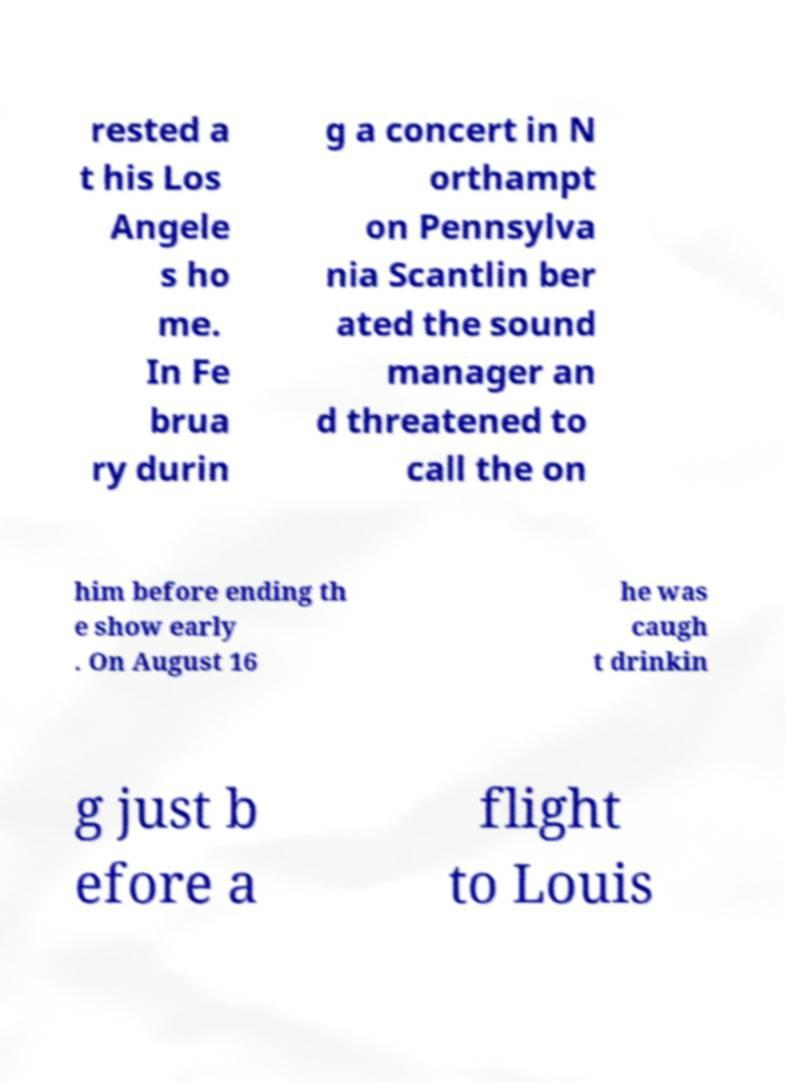Could you assist in decoding the text presented in this image and type it out clearly? rested a t his Los Angele s ho me. In Fe brua ry durin g a concert in N orthampt on Pennsylva nia Scantlin ber ated the sound manager an d threatened to call the on him before ending th e show early . On August 16 he was caugh t drinkin g just b efore a flight to Louis 